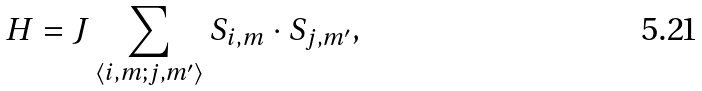Convert formula to latex. <formula><loc_0><loc_0><loc_500><loc_500>H = J \sum _ { \left \langle i , m ; j , m ^ { \prime } \right \rangle } S _ { i , m } \cdot S _ { j , m ^ { \prime } } ,</formula> 